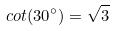Convert formula to latex. <formula><loc_0><loc_0><loc_500><loc_500>c o t ( 3 0 ^ { \circ } ) = \sqrt { 3 }</formula> 